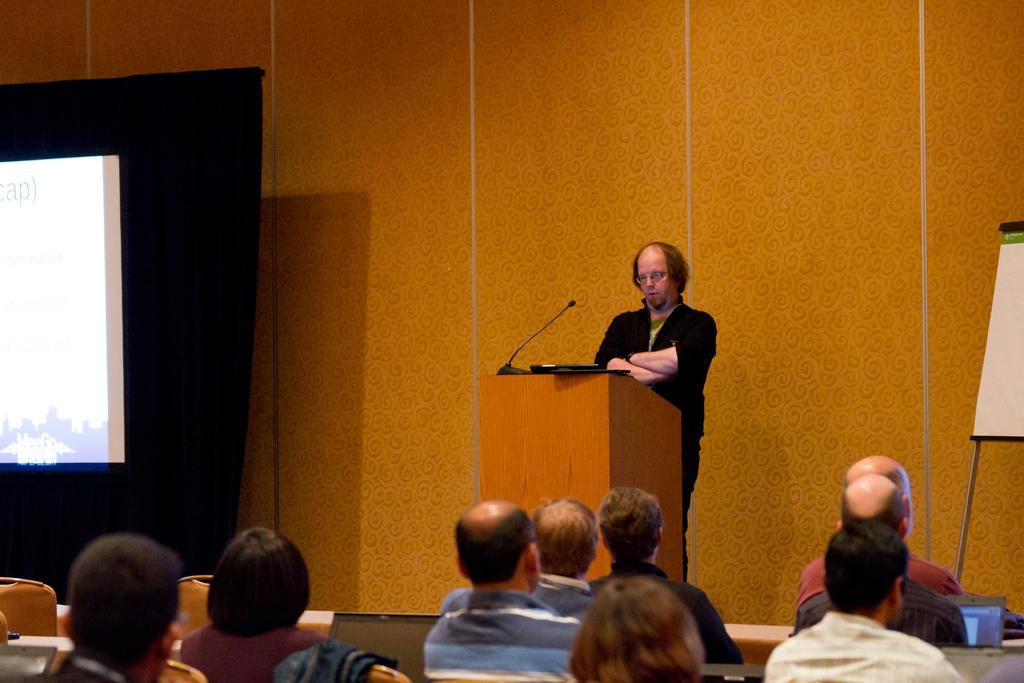What can be seen at the bottom of the image? There is a group of people at the bottom of the image. What is the man near in the middle of the image doing? The man is standing near a podium in the middle of the image. What might be used for displaying visual information in the image? There appears to be a projector screen on the left side of the image. How many oranges are hanging from the projector screen in the image? There are no oranges present in the image, and therefore no such objects can be observed hanging from the projector screen. What type of knot is being used to secure the podium in the image? There is no knot visible in the image, as the podium appears to be standing on its own without any visible support or securing mechanism. 